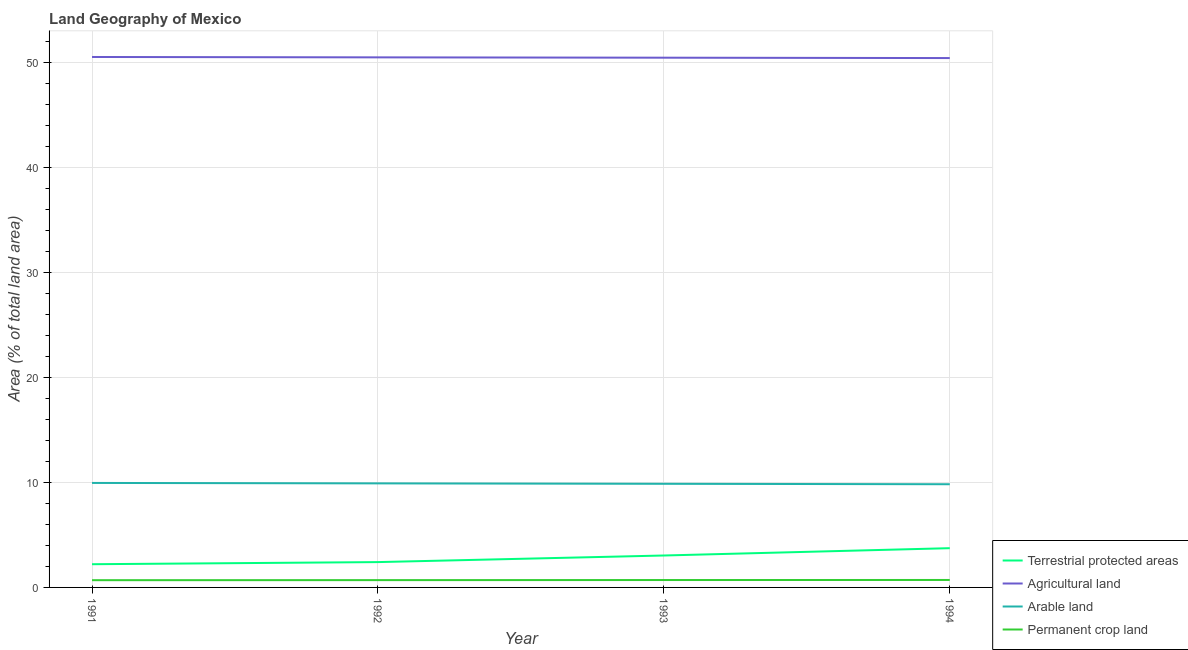What is the percentage of area under permanent crop land in 1991?
Your response must be concise. 0.69. Across all years, what is the maximum percentage of area under permanent crop land?
Your answer should be compact. 0.71. Across all years, what is the minimum percentage of land under terrestrial protection?
Give a very brief answer. 2.21. In which year was the percentage of area under permanent crop land maximum?
Offer a very short reply. 1994. What is the total percentage of land under terrestrial protection in the graph?
Give a very brief answer. 11.4. What is the difference between the percentage of area under agricultural land in 1992 and that in 1994?
Your answer should be very brief. 0.07. What is the difference between the percentage of land under terrestrial protection in 1993 and the percentage of area under arable land in 1991?
Provide a short and direct response. -6.91. What is the average percentage of area under arable land per year?
Offer a terse response. 9.89. In the year 1994, what is the difference between the percentage of land under terrestrial protection and percentage of area under permanent crop land?
Your answer should be very brief. 3.03. In how many years, is the percentage of land under terrestrial protection greater than 16 %?
Provide a short and direct response. 0. What is the ratio of the percentage of land under terrestrial protection in 1991 to that in 1993?
Offer a very short reply. 0.73. What is the difference between the highest and the second highest percentage of land under terrestrial protection?
Give a very brief answer. 0.7. What is the difference between the highest and the lowest percentage of area under permanent crop land?
Offer a very short reply. 0.02. In how many years, is the percentage of area under permanent crop land greater than the average percentage of area under permanent crop land taken over all years?
Provide a succinct answer. 2. Is the sum of the percentage of area under permanent crop land in 1991 and 1993 greater than the maximum percentage of land under terrestrial protection across all years?
Make the answer very short. No. Does the percentage of land under terrestrial protection monotonically increase over the years?
Make the answer very short. Yes. Are the values on the major ticks of Y-axis written in scientific E-notation?
Your answer should be very brief. No. Does the graph contain any zero values?
Give a very brief answer. No. Where does the legend appear in the graph?
Provide a succinct answer. Bottom right. How are the legend labels stacked?
Your answer should be compact. Vertical. What is the title of the graph?
Your answer should be very brief. Land Geography of Mexico. Does "Tertiary schools" appear as one of the legend labels in the graph?
Your answer should be very brief. No. What is the label or title of the X-axis?
Give a very brief answer. Year. What is the label or title of the Y-axis?
Your answer should be very brief. Area (% of total land area). What is the Area (% of total land area) of Terrestrial protected areas in 1991?
Your answer should be very brief. 2.21. What is the Area (% of total land area) in Agricultural land in 1991?
Keep it short and to the point. 50.5. What is the Area (% of total land area) of Arable land in 1991?
Make the answer very short. 9.95. What is the Area (% of total land area) of Permanent crop land in 1991?
Your answer should be compact. 0.69. What is the Area (% of total land area) in Terrestrial protected areas in 1992?
Provide a succinct answer. 2.41. What is the Area (% of total land area) of Agricultural land in 1992?
Ensure brevity in your answer.  50.47. What is the Area (% of total land area) of Arable land in 1992?
Make the answer very short. 9.91. What is the Area (% of total land area) in Permanent crop land in 1992?
Give a very brief answer. 0.69. What is the Area (% of total land area) of Terrestrial protected areas in 1993?
Your answer should be compact. 3.04. What is the Area (% of total land area) of Agricultural land in 1993?
Keep it short and to the point. 50.44. What is the Area (% of total land area) of Arable land in 1993?
Provide a short and direct response. 9.87. What is the Area (% of total land area) of Permanent crop land in 1993?
Offer a terse response. 0.7. What is the Area (% of total land area) in Terrestrial protected areas in 1994?
Provide a succinct answer. 3.74. What is the Area (% of total land area) of Agricultural land in 1994?
Provide a short and direct response. 50.4. What is the Area (% of total land area) of Arable land in 1994?
Keep it short and to the point. 9.83. What is the Area (% of total land area) in Permanent crop land in 1994?
Make the answer very short. 0.71. Across all years, what is the maximum Area (% of total land area) in Terrestrial protected areas?
Your answer should be compact. 3.74. Across all years, what is the maximum Area (% of total land area) in Agricultural land?
Your response must be concise. 50.5. Across all years, what is the maximum Area (% of total land area) of Arable land?
Keep it short and to the point. 9.95. Across all years, what is the maximum Area (% of total land area) in Permanent crop land?
Make the answer very short. 0.71. Across all years, what is the minimum Area (% of total land area) of Terrestrial protected areas?
Provide a short and direct response. 2.21. Across all years, what is the minimum Area (% of total land area) of Agricultural land?
Your answer should be compact. 50.4. Across all years, what is the minimum Area (% of total land area) in Arable land?
Provide a short and direct response. 9.83. Across all years, what is the minimum Area (% of total land area) in Permanent crop land?
Make the answer very short. 0.69. What is the total Area (% of total land area) of Terrestrial protected areas in the graph?
Offer a very short reply. 11.4. What is the total Area (% of total land area) in Agricultural land in the graph?
Provide a short and direct response. 201.81. What is the total Area (% of total land area) in Arable land in the graph?
Make the answer very short. 39.55. What is the total Area (% of total land area) in Permanent crop land in the graph?
Offer a terse response. 2.8. What is the difference between the Area (% of total land area) of Terrestrial protected areas in 1991 and that in 1992?
Your answer should be very brief. -0.2. What is the difference between the Area (% of total land area) of Agricultural land in 1991 and that in 1992?
Your response must be concise. 0.04. What is the difference between the Area (% of total land area) of Arable land in 1991 and that in 1992?
Provide a short and direct response. 0.04. What is the difference between the Area (% of total land area) in Permanent crop land in 1991 and that in 1992?
Offer a terse response. -0.01. What is the difference between the Area (% of total land area) of Terrestrial protected areas in 1991 and that in 1993?
Your answer should be very brief. -0.83. What is the difference between the Area (% of total land area) in Agricultural land in 1991 and that in 1993?
Offer a very short reply. 0.07. What is the difference between the Area (% of total land area) in Arable land in 1991 and that in 1993?
Your response must be concise. 0.08. What is the difference between the Area (% of total land area) of Permanent crop land in 1991 and that in 1993?
Provide a succinct answer. -0.02. What is the difference between the Area (% of total land area) in Terrestrial protected areas in 1991 and that in 1994?
Give a very brief answer. -1.53. What is the difference between the Area (% of total land area) in Agricultural land in 1991 and that in 1994?
Your answer should be very brief. 0.1. What is the difference between the Area (% of total land area) of Arable land in 1991 and that in 1994?
Keep it short and to the point. 0.12. What is the difference between the Area (% of total land area) in Permanent crop land in 1991 and that in 1994?
Offer a very short reply. -0.02. What is the difference between the Area (% of total land area) in Terrestrial protected areas in 1992 and that in 1993?
Keep it short and to the point. -0.63. What is the difference between the Area (% of total land area) in Agricultural land in 1992 and that in 1993?
Your answer should be compact. 0.03. What is the difference between the Area (% of total land area) of Arable land in 1992 and that in 1993?
Make the answer very short. 0.04. What is the difference between the Area (% of total land area) of Permanent crop land in 1992 and that in 1993?
Provide a short and direct response. -0.01. What is the difference between the Area (% of total land area) of Terrestrial protected areas in 1992 and that in 1994?
Provide a short and direct response. -1.32. What is the difference between the Area (% of total land area) in Agricultural land in 1992 and that in 1994?
Give a very brief answer. 0.07. What is the difference between the Area (% of total land area) in Arable land in 1992 and that in 1994?
Make the answer very short. 0.08. What is the difference between the Area (% of total land area) of Permanent crop land in 1992 and that in 1994?
Keep it short and to the point. -0.02. What is the difference between the Area (% of total land area) in Terrestrial protected areas in 1993 and that in 1994?
Give a very brief answer. -0.7. What is the difference between the Area (% of total land area) of Agricultural land in 1993 and that in 1994?
Your response must be concise. 0.04. What is the difference between the Area (% of total land area) of Arable land in 1993 and that in 1994?
Make the answer very short. 0.04. What is the difference between the Area (% of total land area) in Permanent crop land in 1993 and that in 1994?
Make the answer very short. -0.01. What is the difference between the Area (% of total land area) in Terrestrial protected areas in 1991 and the Area (% of total land area) in Agricultural land in 1992?
Give a very brief answer. -48.26. What is the difference between the Area (% of total land area) in Terrestrial protected areas in 1991 and the Area (% of total land area) in Arable land in 1992?
Give a very brief answer. -7.7. What is the difference between the Area (% of total land area) of Terrestrial protected areas in 1991 and the Area (% of total land area) of Permanent crop land in 1992?
Keep it short and to the point. 1.52. What is the difference between the Area (% of total land area) of Agricultural land in 1991 and the Area (% of total land area) of Arable land in 1992?
Ensure brevity in your answer.  40.6. What is the difference between the Area (% of total land area) of Agricultural land in 1991 and the Area (% of total land area) of Permanent crop land in 1992?
Ensure brevity in your answer.  49.81. What is the difference between the Area (% of total land area) of Arable land in 1991 and the Area (% of total land area) of Permanent crop land in 1992?
Provide a short and direct response. 9.25. What is the difference between the Area (% of total land area) of Terrestrial protected areas in 1991 and the Area (% of total land area) of Agricultural land in 1993?
Make the answer very short. -48.23. What is the difference between the Area (% of total land area) in Terrestrial protected areas in 1991 and the Area (% of total land area) in Arable land in 1993?
Keep it short and to the point. -7.66. What is the difference between the Area (% of total land area) of Terrestrial protected areas in 1991 and the Area (% of total land area) of Permanent crop land in 1993?
Offer a very short reply. 1.51. What is the difference between the Area (% of total land area) in Agricultural land in 1991 and the Area (% of total land area) in Arable land in 1993?
Provide a short and direct response. 40.64. What is the difference between the Area (% of total land area) in Agricultural land in 1991 and the Area (% of total land area) in Permanent crop land in 1993?
Make the answer very short. 49.8. What is the difference between the Area (% of total land area) of Arable land in 1991 and the Area (% of total land area) of Permanent crop land in 1993?
Provide a succinct answer. 9.24. What is the difference between the Area (% of total land area) of Terrestrial protected areas in 1991 and the Area (% of total land area) of Agricultural land in 1994?
Your response must be concise. -48.19. What is the difference between the Area (% of total land area) of Terrestrial protected areas in 1991 and the Area (% of total land area) of Arable land in 1994?
Offer a very short reply. -7.62. What is the difference between the Area (% of total land area) in Terrestrial protected areas in 1991 and the Area (% of total land area) in Permanent crop land in 1994?
Your response must be concise. 1.5. What is the difference between the Area (% of total land area) in Agricultural land in 1991 and the Area (% of total land area) in Arable land in 1994?
Keep it short and to the point. 40.68. What is the difference between the Area (% of total land area) of Agricultural land in 1991 and the Area (% of total land area) of Permanent crop land in 1994?
Offer a very short reply. 49.8. What is the difference between the Area (% of total land area) of Arable land in 1991 and the Area (% of total land area) of Permanent crop land in 1994?
Offer a very short reply. 9.24. What is the difference between the Area (% of total land area) in Terrestrial protected areas in 1992 and the Area (% of total land area) in Agricultural land in 1993?
Give a very brief answer. -48.03. What is the difference between the Area (% of total land area) in Terrestrial protected areas in 1992 and the Area (% of total land area) in Arable land in 1993?
Give a very brief answer. -7.45. What is the difference between the Area (% of total land area) in Terrestrial protected areas in 1992 and the Area (% of total land area) in Permanent crop land in 1993?
Keep it short and to the point. 1.71. What is the difference between the Area (% of total land area) in Agricultural land in 1992 and the Area (% of total land area) in Arable land in 1993?
Provide a succinct answer. 40.6. What is the difference between the Area (% of total land area) of Agricultural land in 1992 and the Area (% of total land area) of Permanent crop land in 1993?
Offer a terse response. 49.76. What is the difference between the Area (% of total land area) in Arable land in 1992 and the Area (% of total land area) in Permanent crop land in 1993?
Provide a short and direct response. 9.2. What is the difference between the Area (% of total land area) of Terrestrial protected areas in 1992 and the Area (% of total land area) of Agricultural land in 1994?
Your answer should be compact. -47.99. What is the difference between the Area (% of total land area) of Terrestrial protected areas in 1992 and the Area (% of total land area) of Arable land in 1994?
Provide a succinct answer. -7.41. What is the difference between the Area (% of total land area) of Terrestrial protected areas in 1992 and the Area (% of total land area) of Permanent crop land in 1994?
Your response must be concise. 1.7. What is the difference between the Area (% of total land area) in Agricultural land in 1992 and the Area (% of total land area) in Arable land in 1994?
Provide a succinct answer. 40.64. What is the difference between the Area (% of total land area) of Agricultural land in 1992 and the Area (% of total land area) of Permanent crop land in 1994?
Make the answer very short. 49.76. What is the difference between the Area (% of total land area) of Arable land in 1992 and the Area (% of total land area) of Permanent crop land in 1994?
Provide a succinct answer. 9.2. What is the difference between the Area (% of total land area) in Terrestrial protected areas in 1993 and the Area (% of total land area) in Agricultural land in 1994?
Offer a terse response. -47.36. What is the difference between the Area (% of total land area) in Terrestrial protected areas in 1993 and the Area (% of total land area) in Arable land in 1994?
Make the answer very short. -6.79. What is the difference between the Area (% of total land area) in Terrestrial protected areas in 1993 and the Area (% of total land area) in Permanent crop land in 1994?
Your response must be concise. 2.33. What is the difference between the Area (% of total land area) in Agricultural land in 1993 and the Area (% of total land area) in Arable land in 1994?
Ensure brevity in your answer.  40.61. What is the difference between the Area (% of total land area) of Agricultural land in 1993 and the Area (% of total land area) of Permanent crop land in 1994?
Ensure brevity in your answer.  49.73. What is the difference between the Area (% of total land area) of Arable land in 1993 and the Area (% of total land area) of Permanent crop land in 1994?
Your response must be concise. 9.16. What is the average Area (% of total land area) in Terrestrial protected areas per year?
Offer a very short reply. 2.85. What is the average Area (% of total land area) of Agricultural land per year?
Your response must be concise. 50.45. What is the average Area (% of total land area) of Arable land per year?
Provide a succinct answer. 9.89. What is the average Area (% of total land area) of Permanent crop land per year?
Keep it short and to the point. 0.7. In the year 1991, what is the difference between the Area (% of total land area) in Terrestrial protected areas and Area (% of total land area) in Agricultural land?
Your answer should be very brief. -48.29. In the year 1991, what is the difference between the Area (% of total land area) of Terrestrial protected areas and Area (% of total land area) of Arable land?
Ensure brevity in your answer.  -7.74. In the year 1991, what is the difference between the Area (% of total land area) of Terrestrial protected areas and Area (% of total land area) of Permanent crop land?
Keep it short and to the point. 1.52. In the year 1991, what is the difference between the Area (% of total land area) in Agricultural land and Area (% of total land area) in Arable land?
Your response must be concise. 40.56. In the year 1991, what is the difference between the Area (% of total land area) of Agricultural land and Area (% of total land area) of Permanent crop land?
Your answer should be compact. 49.82. In the year 1991, what is the difference between the Area (% of total land area) of Arable land and Area (% of total land area) of Permanent crop land?
Your answer should be very brief. 9.26. In the year 1992, what is the difference between the Area (% of total land area) of Terrestrial protected areas and Area (% of total land area) of Agricultural land?
Make the answer very short. -48.06. In the year 1992, what is the difference between the Area (% of total land area) of Terrestrial protected areas and Area (% of total land area) of Arable land?
Offer a very short reply. -7.5. In the year 1992, what is the difference between the Area (% of total land area) of Terrestrial protected areas and Area (% of total land area) of Permanent crop land?
Offer a very short reply. 1.72. In the year 1992, what is the difference between the Area (% of total land area) in Agricultural land and Area (% of total land area) in Arable land?
Your answer should be compact. 40.56. In the year 1992, what is the difference between the Area (% of total land area) in Agricultural land and Area (% of total land area) in Permanent crop land?
Provide a short and direct response. 49.77. In the year 1992, what is the difference between the Area (% of total land area) of Arable land and Area (% of total land area) of Permanent crop land?
Your response must be concise. 9.21. In the year 1993, what is the difference between the Area (% of total land area) in Terrestrial protected areas and Area (% of total land area) in Agricultural land?
Your answer should be compact. -47.4. In the year 1993, what is the difference between the Area (% of total land area) of Terrestrial protected areas and Area (% of total land area) of Arable land?
Offer a very short reply. -6.83. In the year 1993, what is the difference between the Area (% of total land area) in Terrestrial protected areas and Area (% of total land area) in Permanent crop land?
Provide a succinct answer. 2.34. In the year 1993, what is the difference between the Area (% of total land area) in Agricultural land and Area (% of total land area) in Arable land?
Your answer should be compact. 40.57. In the year 1993, what is the difference between the Area (% of total land area) in Agricultural land and Area (% of total land area) in Permanent crop land?
Provide a short and direct response. 49.73. In the year 1993, what is the difference between the Area (% of total land area) in Arable land and Area (% of total land area) in Permanent crop land?
Your response must be concise. 9.16. In the year 1994, what is the difference between the Area (% of total land area) in Terrestrial protected areas and Area (% of total land area) in Agricultural land?
Keep it short and to the point. -46.66. In the year 1994, what is the difference between the Area (% of total land area) in Terrestrial protected areas and Area (% of total land area) in Arable land?
Ensure brevity in your answer.  -6.09. In the year 1994, what is the difference between the Area (% of total land area) of Terrestrial protected areas and Area (% of total land area) of Permanent crop land?
Keep it short and to the point. 3.03. In the year 1994, what is the difference between the Area (% of total land area) in Agricultural land and Area (% of total land area) in Arable land?
Provide a short and direct response. 40.58. In the year 1994, what is the difference between the Area (% of total land area) in Agricultural land and Area (% of total land area) in Permanent crop land?
Offer a very short reply. 49.69. In the year 1994, what is the difference between the Area (% of total land area) of Arable land and Area (% of total land area) of Permanent crop land?
Offer a terse response. 9.12. What is the ratio of the Area (% of total land area) of Terrestrial protected areas in 1991 to that in 1992?
Your response must be concise. 0.92. What is the ratio of the Area (% of total land area) in Agricultural land in 1991 to that in 1992?
Offer a terse response. 1. What is the ratio of the Area (% of total land area) in Terrestrial protected areas in 1991 to that in 1993?
Your response must be concise. 0.73. What is the ratio of the Area (% of total land area) in Arable land in 1991 to that in 1993?
Give a very brief answer. 1.01. What is the ratio of the Area (% of total land area) of Permanent crop land in 1991 to that in 1993?
Provide a succinct answer. 0.98. What is the ratio of the Area (% of total land area) in Terrestrial protected areas in 1991 to that in 1994?
Your response must be concise. 0.59. What is the ratio of the Area (% of total land area) in Agricultural land in 1991 to that in 1994?
Offer a terse response. 1. What is the ratio of the Area (% of total land area) of Arable land in 1991 to that in 1994?
Make the answer very short. 1.01. What is the ratio of the Area (% of total land area) of Permanent crop land in 1991 to that in 1994?
Offer a very short reply. 0.97. What is the ratio of the Area (% of total land area) in Terrestrial protected areas in 1992 to that in 1993?
Give a very brief answer. 0.79. What is the ratio of the Area (% of total land area) in Agricultural land in 1992 to that in 1993?
Your response must be concise. 1. What is the ratio of the Area (% of total land area) of Permanent crop land in 1992 to that in 1993?
Your response must be concise. 0.99. What is the ratio of the Area (% of total land area) of Terrestrial protected areas in 1992 to that in 1994?
Provide a short and direct response. 0.65. What is the ratio of the Area (% of total land area) in Agricultural land in 1992 to that in 1994?
Your answer should be very brief. 1. What is the ratio of the Area (% of total land area) in Arable land in 1992 to that in 1994?
Offer a terse response. 1.01. What is the ratio of the Area (% of total land area) in Permanent crop land in 1992 to that in 1994?
Provide a succinct answer. 0.98. What is the ratio of the Area (% of total land area) of Terrestrial protected areas in 1993 to that in 1994?
Offer a terse response. 0.81. What is the ratio of the Area (% of total land area) of Agricultural land in 1993 to that in 1994?
Give a very brief answer. 1. What is the ratio of the Area (% of total land area) of Arable land in 1993 to that in 1994?
Offer a terse response. 1. What is the difference between the highest and the second highest Area (% of total land area) in Terrestrial protected areas?
Your response must be concise. 0.7. What is the difference between the highest and the second highest Area (% of total land area) in Agricultural land?
Your answer should be compact. 0.04. What is the difference between the highest and the second highest Area (% of total land area) of Arable land?
Provide a short and direct response. 0.04. What is the difference between the highest and the second highest Area (% of total land area) of Permanent crop land?
Give a very brief answer. 0.01. What is the difference between the highest and the lowest Area (% of total land area) in Terrestrial protected areas?
Give a very brief answer. 1.53. What is the difference between the highest and the lowest Area (% of total land area) in Agricultural land?
Provide a short and direct response. 0.1. What is the difference between the highest and the lowest Area (% of total land area) of Arable land?
Make the answer very short. 0.12. What is the difference between the highest and the lowest Area (% of total land area) in Permanent crop land?
Your response must be concise. 0.02. 